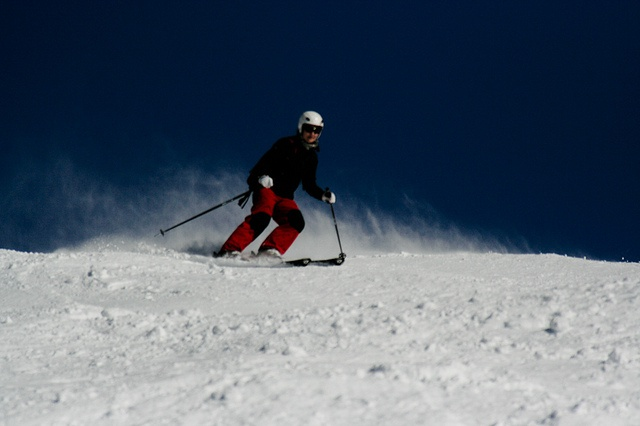Describe the objects in this image and their specific colors. I can see people in black, maroon, gray, and darkgray tones and skis in black, darkgray, and gray tones in this image. 